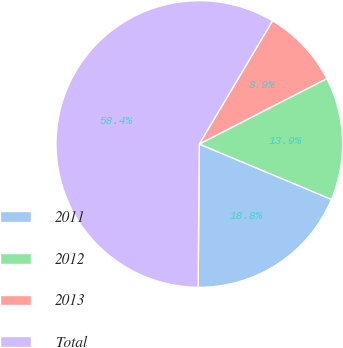Convert chart. <chart><loc_0><loc_0><loc_500><loc_500><pie_chart><fcel>2011<fcel>2012<fcel>2013<fcel>Total<nl><fcel>18.81%<fcel>13.86%<fcel>8.92%<fcel>58.41%<nl></chart> 